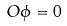<formula> <loc_0><loc_0><loc_500><loc_500>O \phi = 0</formula> 